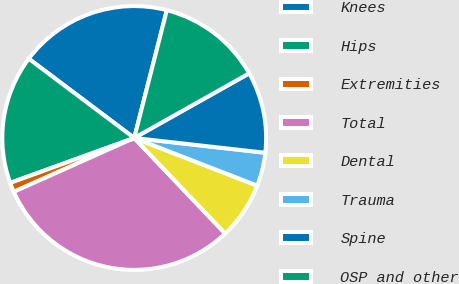<chart> <loc_0><loc_0><loc_500><loc_500><pie_chart><fcel>Knees<fcel>Hips<fcel>Extremities<fcel>Total<fcel>Dental<fcel>Trauma<fcel>Spine<fcel>OSP and other<nl><fcel>18.72%<fcel>15.79%<fcel>1.16%<fcel>30.42%<fcel>7.01%<fcel>4.09%<fcel>9.94%<fcel>12.87%<nl></chart> 